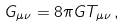Convert formula to latex. <formula><loc_0><loc_0><loc_500><loc_500>G _ { \mu \nu } = 8 \pi G T _ { \mu \nu } \, ,</formula> 